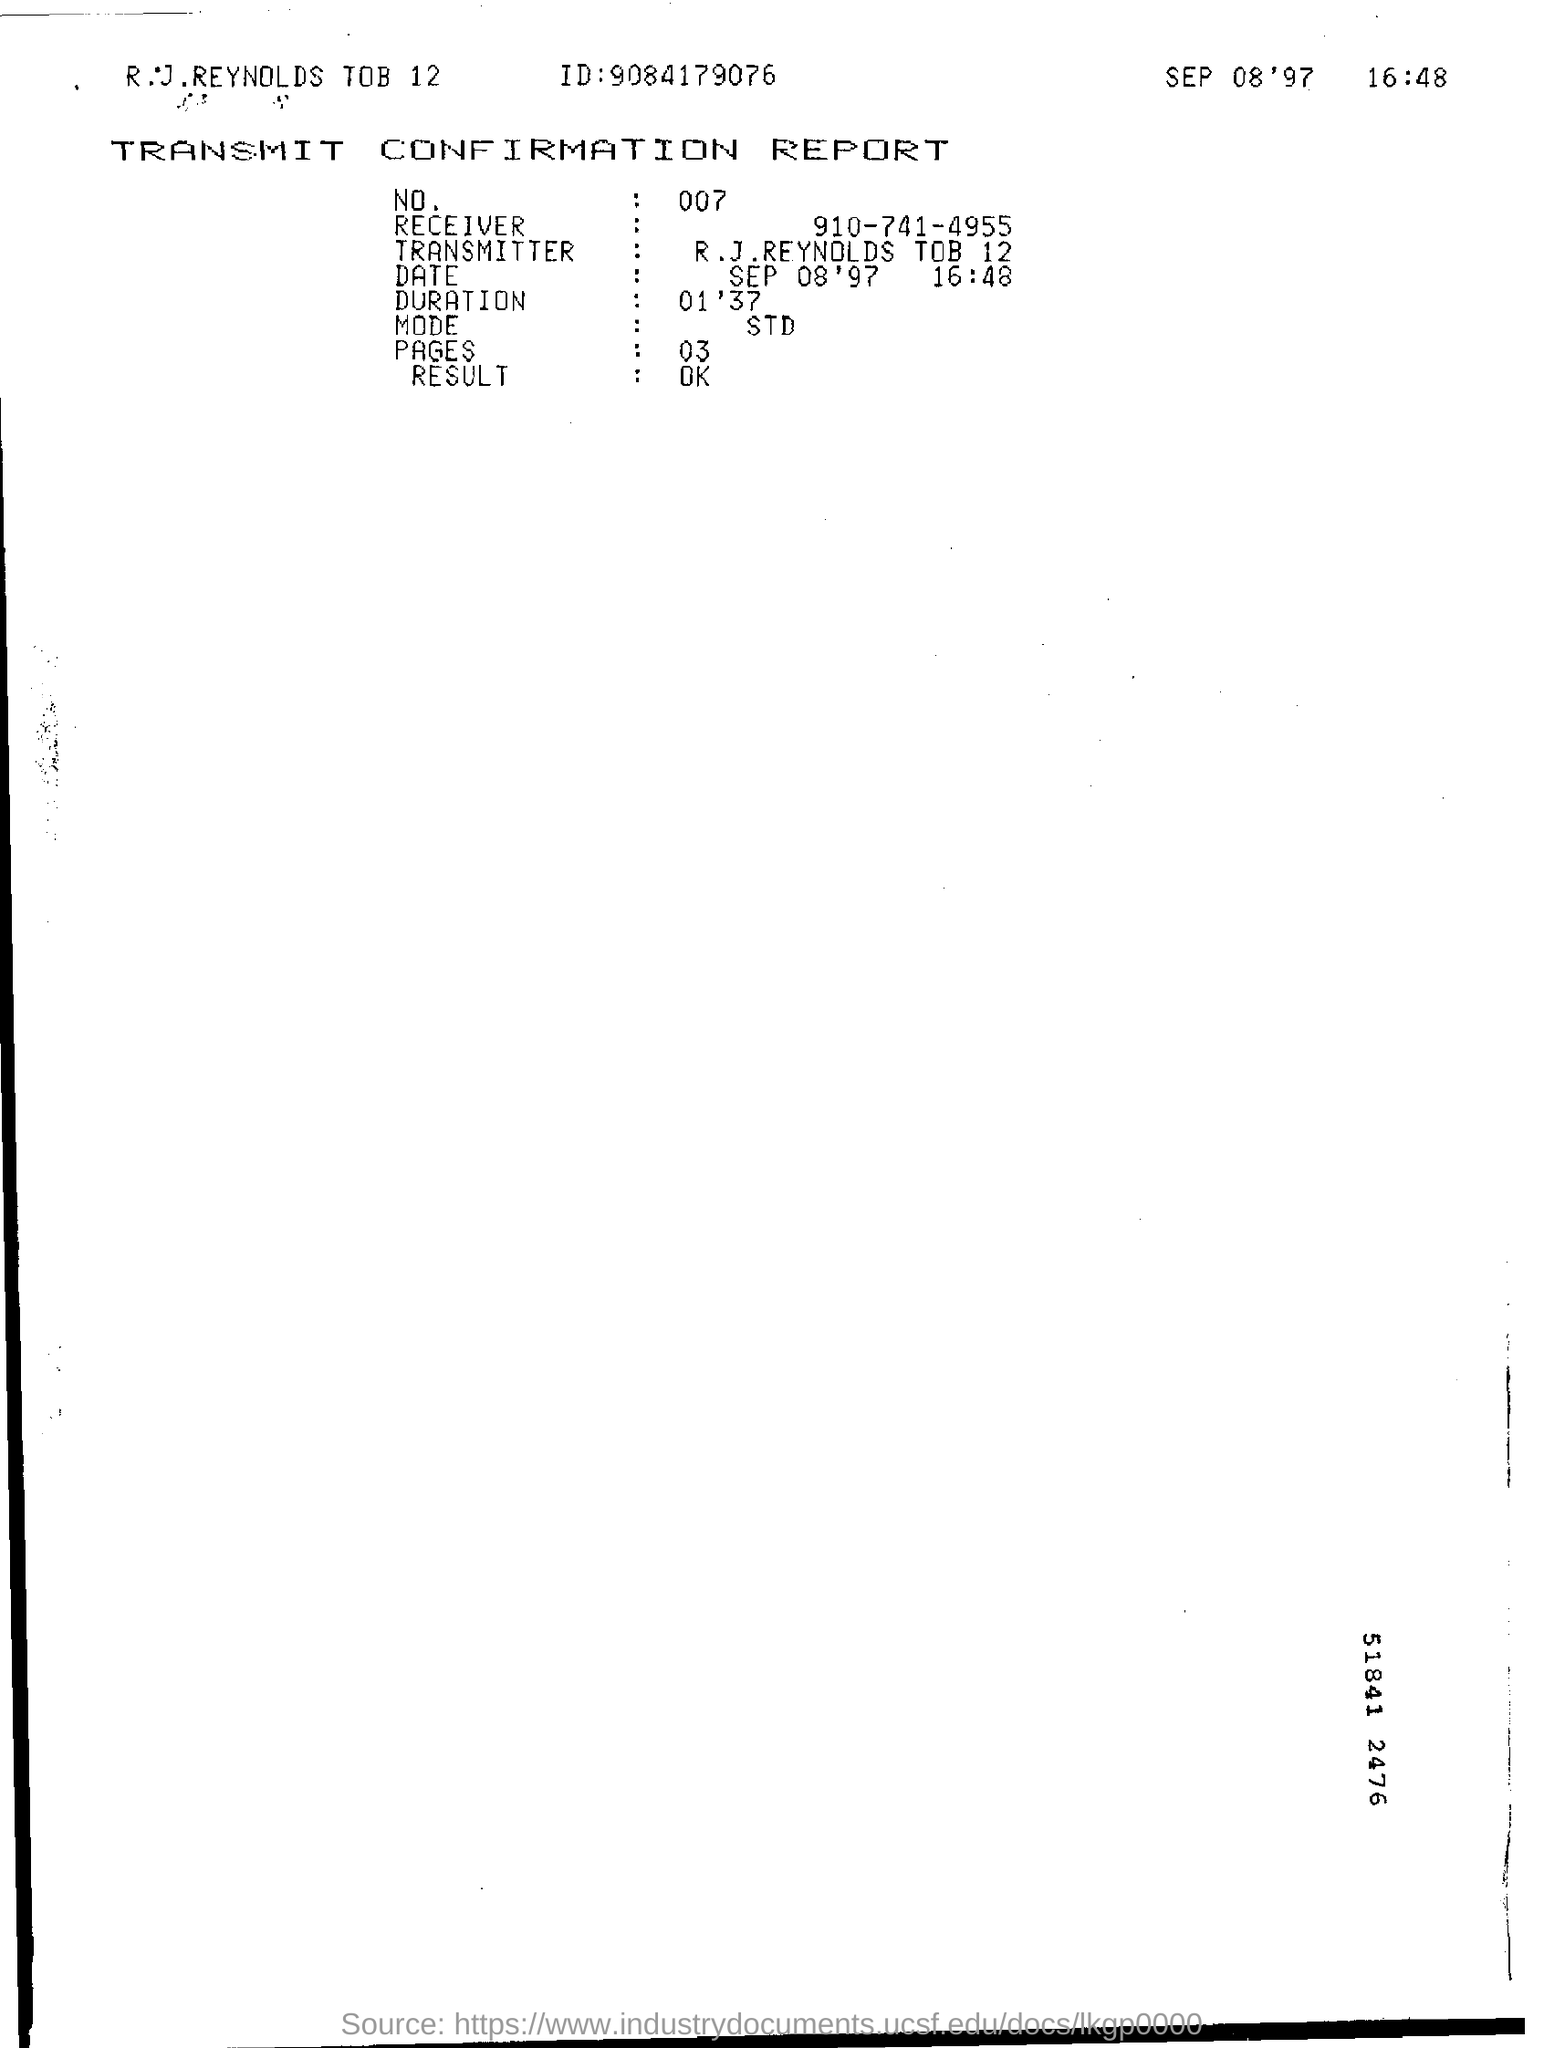What type of documentation is this?
Provide a short and direct response. Transmit confirmation report. What is the number on report?
Your answer should be compact. 007. What is the ID mentioned in the report?
Your answer should be very brief. 9084179076. What is the mode mentioned?
Provide a succinct answer. STD. 